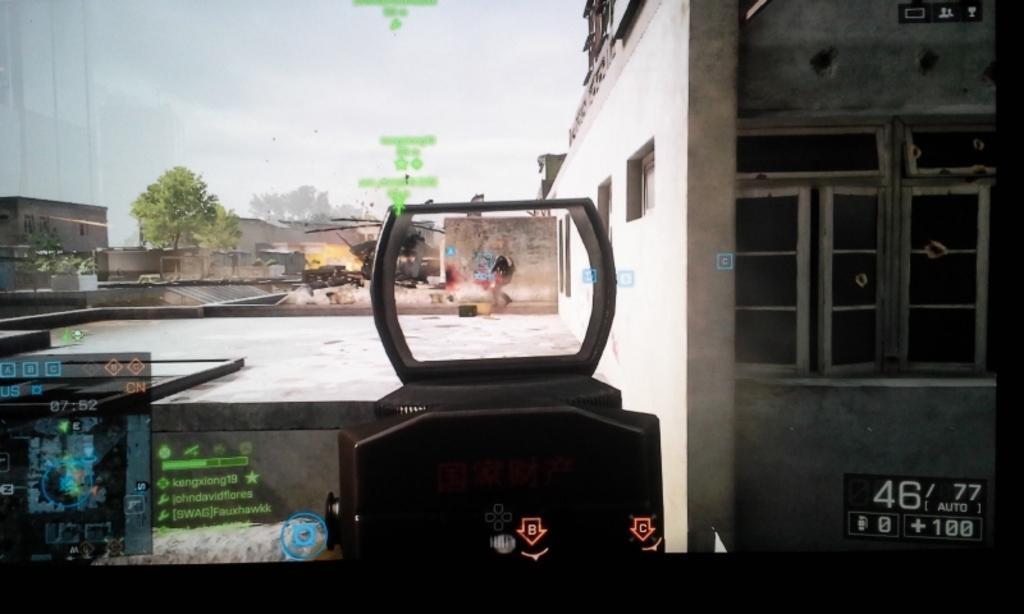Could you give a brief overview of what you see in this image? This is an animated picture. In the foreground we can see numbers, text and the top part of the gun. Towards right there are buildings. On the left there are buildings and trees. In the middle of the picture we can see buildings and some explosions. At the top it is sky. 